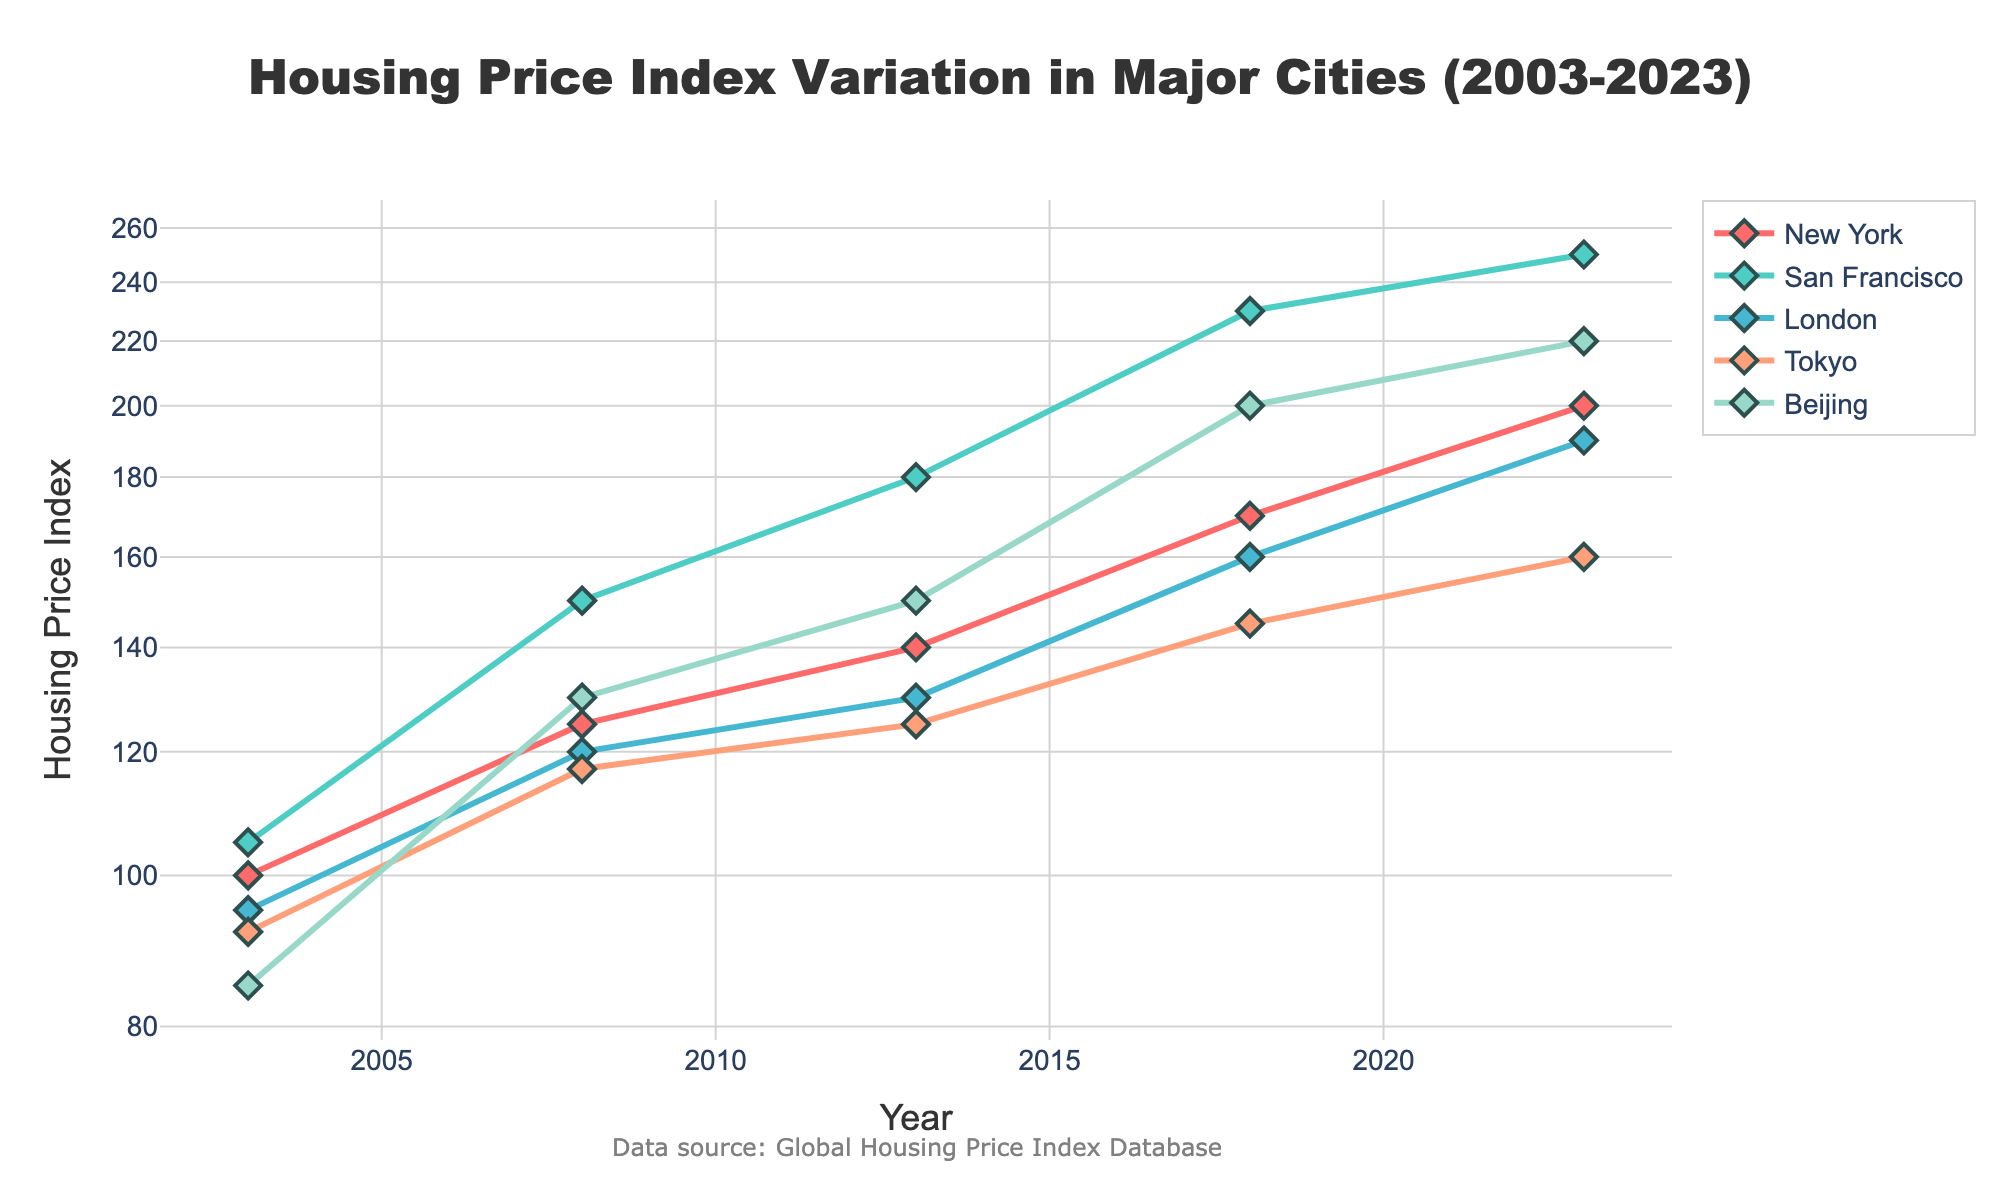What is the title of the figure? The title of the figure is typically displayed prominently at the top. To find it, simply look at the top central area where the text describes the figure’s main subject.
Answer: Housing Price Index Variation in Major Cities (2003-2023) What is the y-axis title in the figure? The y-axis title is found along the vertical axis of the graph and it indicates what is being measured.
Answer: Housing Price Index How many cities' housing price indexes are shown in the figure? The number of cities can be identified by looking at the legend or the different colored lines in the plot.
Answer: 5 Which city had the highest housing price index in 2023? To find this, locate the data points for 2023 on the x-axis and compare the height of the points for each city.
Answer: San Francisco What is the overall trend in housing prices from 2003 to 2023 in Beijing? Look at the line representing Beijing from 2003 to 2023. If the line generally slopes upwards, then the trend is an increase.
Answer: Increasing By how much did the housing price index for New York change from 2008 to 2013? Find the data points for New York in 2008 and 2013 and then calculate the difference between these two values.
Answer: 15 Which city experienced the greatest increase in the housing price index from 2008 to 2013? Calculate the difference between the 2008 and 2013 values for each city and compare them to find the greatest increase.
Answer: Beijing In which year did London surpass 150 on the housing price index? Identify when London’s data points first reach above 150 on the y-axis by examining each point from left to right.
Answer: 2018 Does any city show a decrease in the housing price index at any point between 2003 and 2023? Analyze each line to see if there is any downward slope over any segment.
Answer: No Compare the housing price index of Tokyo and London in 2023. Which city has a higher index? Locate the 2023 data points for both Tokyo and London and compare their y-values.
Answer: London 